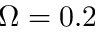<formula> <loc_0><loc_0><loc_500><loc_500>\Omega = 0 . 2</formula> 